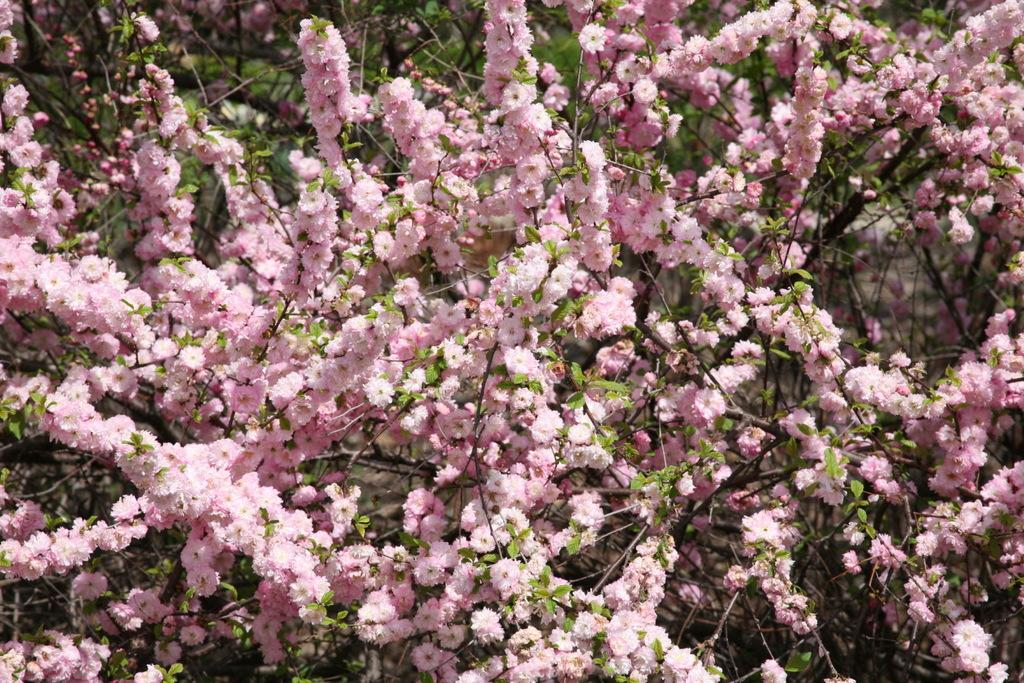What type of flowers can be seen in the image? There are pink color flowers in the image. What else can be seen in the background of the image? There are leaves in the background of the image. What team is playing in the harbor in the image? There is no team or harbor present in the image; it features pink color flowers and leaves in the background. 